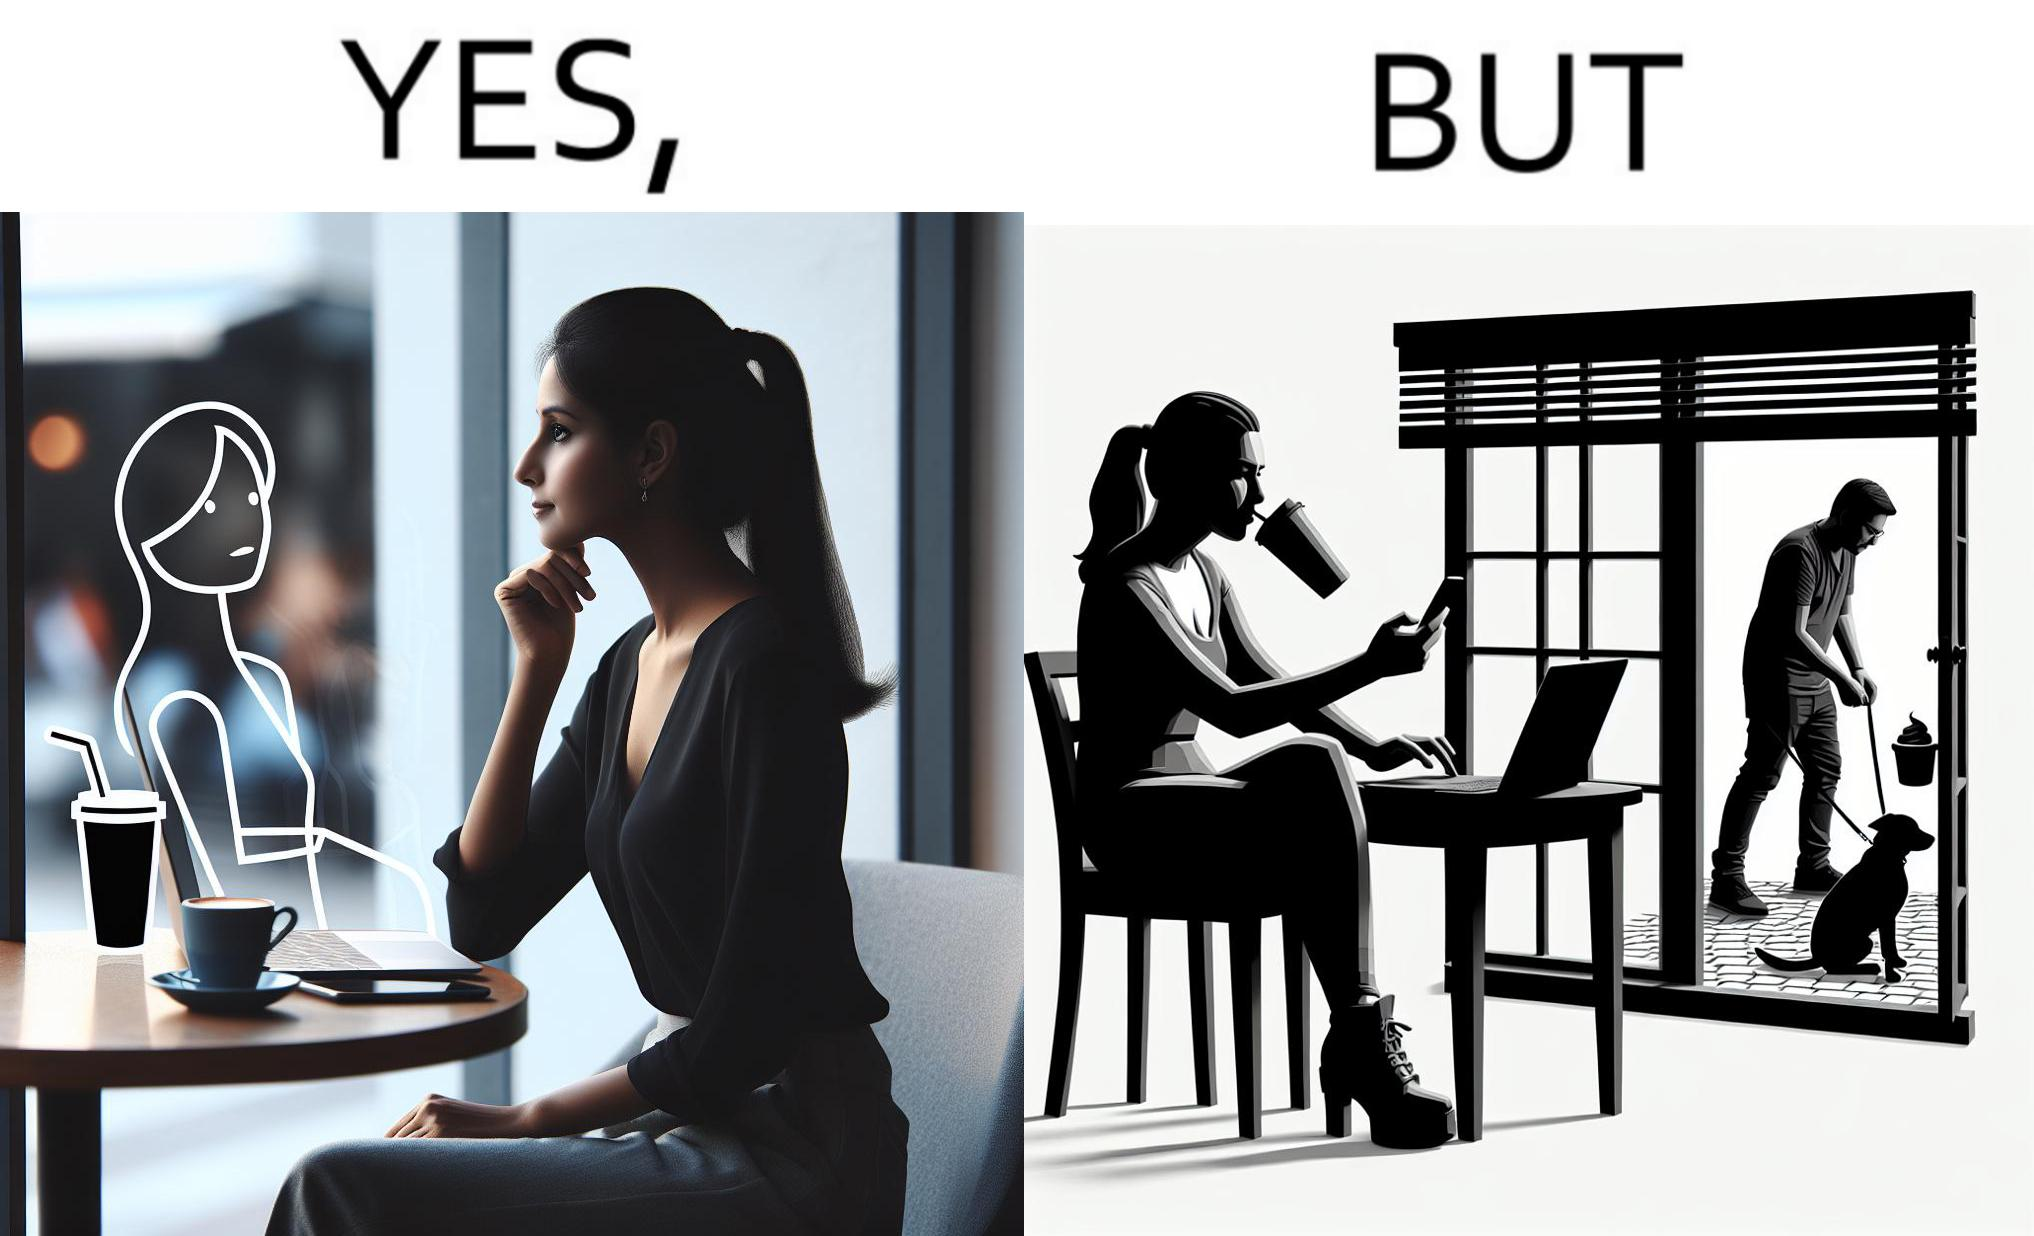Is this a satirical image? Yes, this image is satirical. 